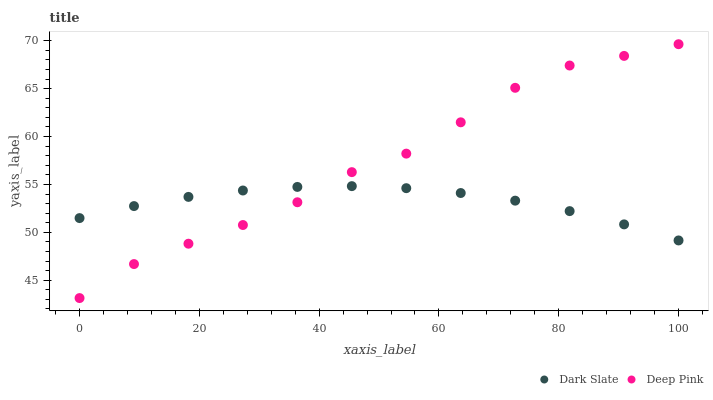Does Dark Slate have the minimum area under the curve?
Answer yes or no. Yes. Does Deep Pink have the maximum area under the curve?
Answer yes or no. Yes. Does Deep Pink have the minimum area under the curve?
Answer yes or no. No. Is Dark Slate the smoothest?
Answer yes or no. Yes. Is Deep Pink the roughest?
Answer yes or no. Yes. Is Deep Pink the smoothest?
Answer yes or no. No. Does Deep Pink have the lowest value?
Answer yes or no. Yes. Does Deep Pink have the highest value?
Answer yes or no. Yes. Does Deep Pink intersect Dark Slate?
Answer yes or no. Yes. Is Deep Pink less than Dark Slate?
Answer yes or no. No. Is Deep Pink greater than Dark Slate?
Answer yes or no. No. 